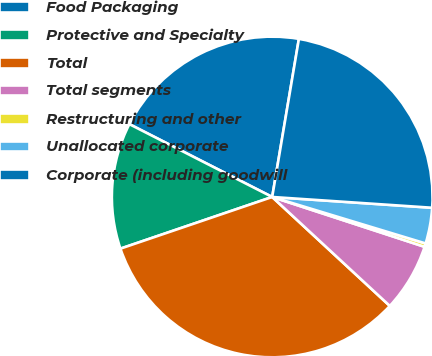Convert chart to OTSL. <chart><loc_0><loc_0><loc_500><loc_500><pie_chart><fcel>Food Packaging<fcel>Protective and Specialty<fcel>Total<fcel>Total segments<fcel>Restructuring and other<fcel>Unallocated corporate<fcel>Corporate (including goodwill<nl><fcel>20.16%<fcel>12.73%<fcel>32.89%<fcel>6.86%<fcel>0.35%<fcel>3.61%<fcel>23.41%<nl></chart> 